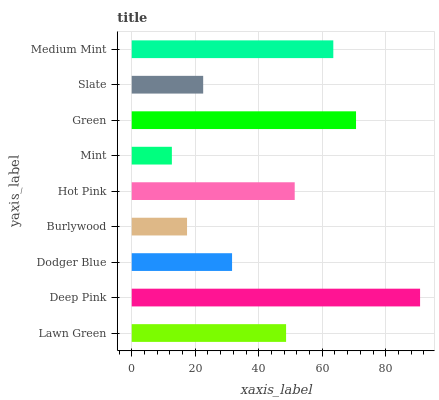Is Mint the minimum?
Answer yes or no. Yes. Is Deep Pink the maximum?
Answer yes or no. Yes. Is Dodger Blue the minimum?
Answer yes or no. No. Is Dodger Blue the maximum?
Answer yes or no. No. Is Deep Pink greater than Dodger Blue?
Answer yes or no. Yes. Is Dodger Blue less than Deep Pink?
Answer yes or no. Yes. Is Dodger Blue greater than Deep Pink?
Answer yes or no. No. Is Deep Pink less than Dodger Blue?
Answer yes or no. No. Is Lawn Green the high median?
Answer yes or no. Yes. Is Lawn Green the low median?
Answer yes or no. Yes. Is Medium Mint the high median?
Answer yes or no. No. Is Burlywood the low median?
Answer yes or no. No. 